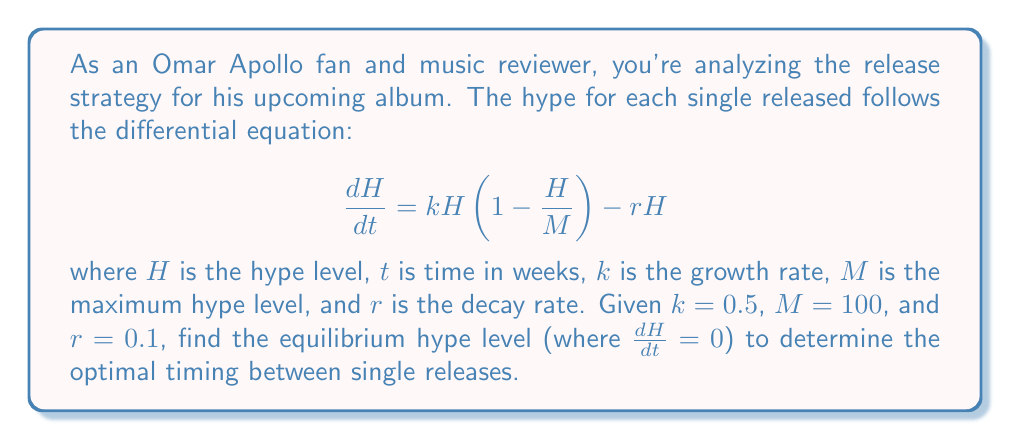Solve this math problem. To find the equilibrium hype level, we need to set the differential equation equal to zero and solve for $H$:

$$\frac{dH}{dt} = kH(1 - \frac{H}{M}) - rH = 0$$

Substituting the given values:

$$0.5H(1 - \frac{H}{100}) - 0.1H = 0$$

Factoring out $H$:

$$H(0.5(1 - \frac{H}{100}) - 0.1) = 0$$

This equation is satisfied when $H = 0$ or when the term in parentheses equals zero. Let's solve the latter:

$$0.5(1 - \frac{H}{100}) - 0.1 = 0$$

$$0.5 - \frac{0.5H}{100} - 0.1 = 0$$

$$0.4 - \frac{0.5H}{100} = 0$$

$$0.4 = \frac{0.5H}{100}$$

$$40 = 0.5H$$

$$H = 80$$

Therefore, the non-zero equilibrium hype level is 80.
Answer: The equilibrium hype level is 80, indicating that singles should be released when the hype from the previous single approaches this level to maintain optimal excitement for the album. 